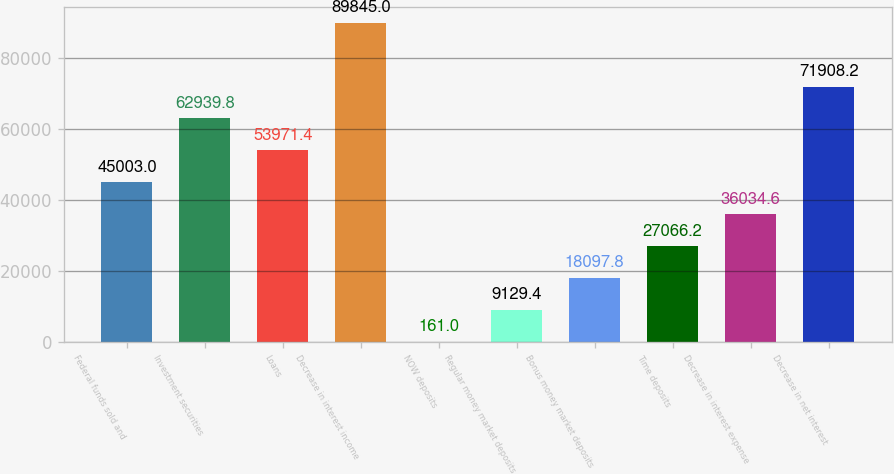Convert chart. <chart><loc_0><loc_0><loc_500><loc_500><bar_chart><fcel>Federal funds sold and<fcel>Investment securities<fcel>Loans<fcel>Decrease in interest income<fcel>NOW deposits<fcel>Regular money market deposits<fcel>Bonus money market deposits<fcel>Time deposits<fcel>Decrease in interest expense<fcel>Decrease in net interest<nl><fcel>45003<fcel>62939.8<fcel>53971.4<fcel>89845<fcel>161<fcel>9129.4<fcel>18097.8<fcel>27066.2<fcel>36034.6<fcel>71908.2<nl></chart> 